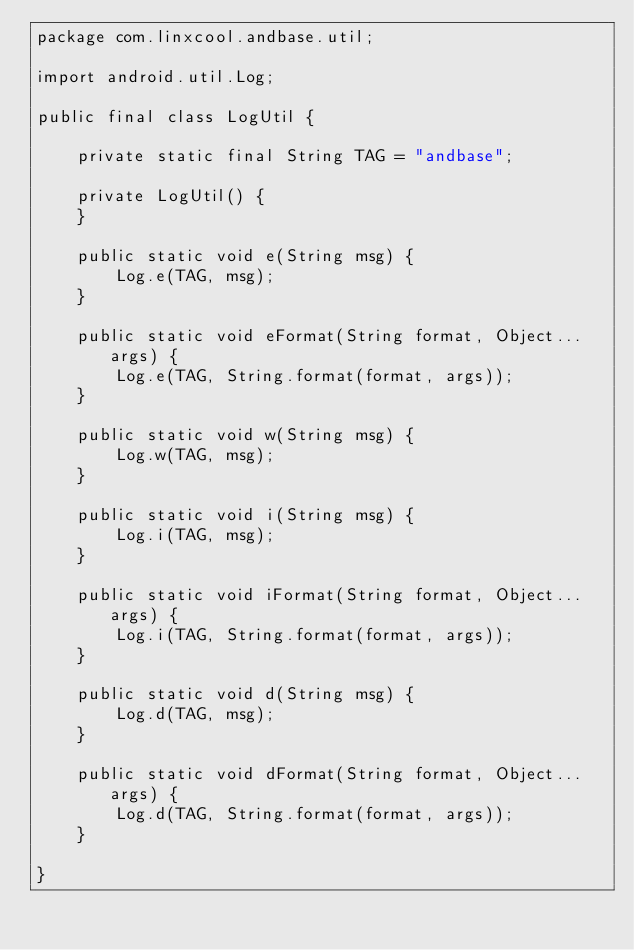Convert code to text. <code><loc_0><loc_0><loc_500><loc_500><_Java_>package com.linxcool.andbase.util;

import android.util.Log;

public final class LogUtil {

    private static final String TAG = "andbase";

    private LogUtil() {
    }

    public static void e(String msg) {
        Log.e(TAG, msg);
    }

    public static void eFormat(String format, Object... args) {
        Log.e(TAG, String.format(format, args));
    }

    public static void w(String msg) {
        Log.w(TAG, msg);
    }

    public static void i(String msg) {
        Log.i(TAG, msg);
    }

    public static void iFormat(String format, Object... args) {
        Log.i(TAG, String.format(format, args));
    }

    public static void d(String msg) {
        Log.d(TAG, msg);
    }

    public static void dFormat(String format, Object... args) {
        Log.d(TAG, String.format(format, args));
    }

}
</code> 